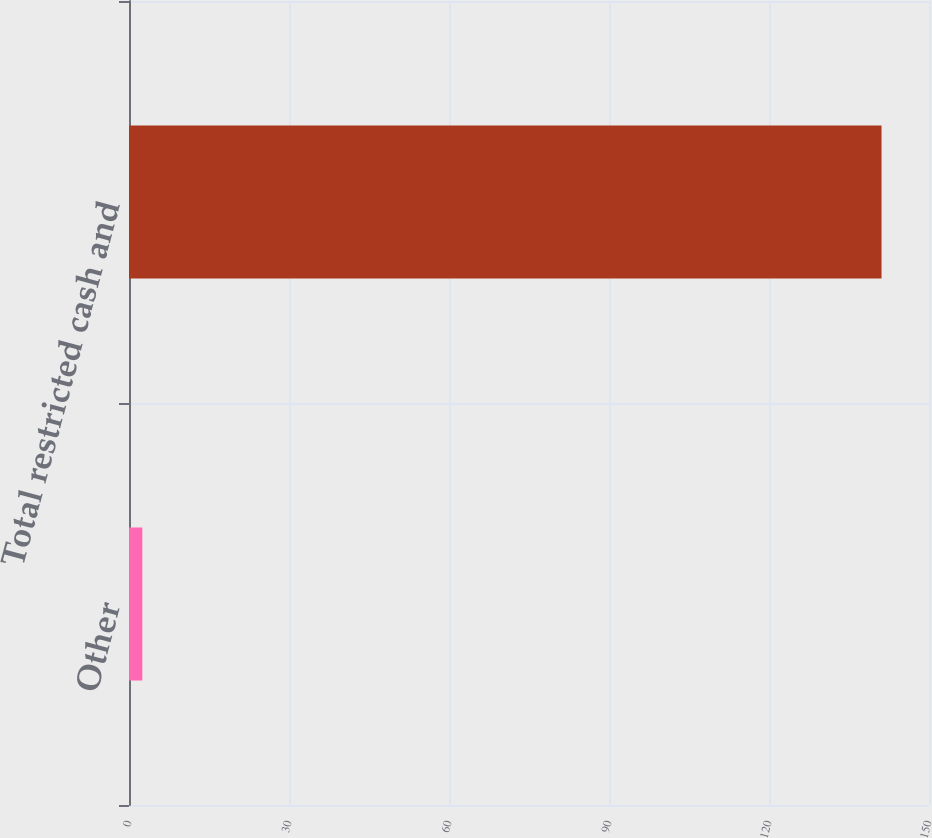Convert chart to OTSL. <chart><loc_0><loc_0><loc_500><loc_500><bar_chart><fcel>Other<fcel>Total restricted cash and<nl><fcel>2.5<fcel>141.1<nl></chart> 